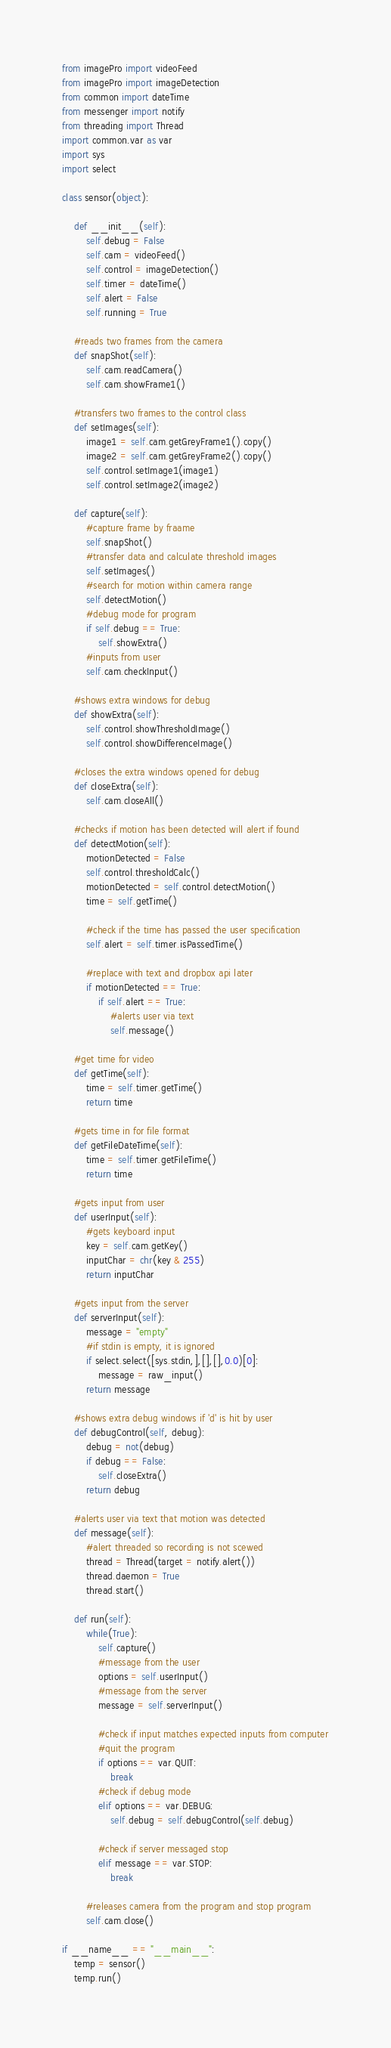Convert code to text. <code><loc_0><loc_0><loc_500><loc_500><_Python_>from imagePro import videoFeed
from imagePro import imageDetection
from common import dateTime
from messenger import notify
from threading import Thread
import common.var as var
import sys
import select

class sensor(object):

    def __init__(self):
        self.debug = False
        self.cam = videoFeed()
        self.control = imageDetection()
        self.timer = dateTime()
        self.alert = False
        self.running = True

    #reads two frames from the camera
    def snapShot(self):
        self.cam.readCamera()
        self.cam.showFrame1()

    #transfers two frames to the control class
    def setImages(self):
        image1 = self.cam.getGreyFrame1().copy()
        image2 = self.cam.getGreyFrame2().copy()
        self.control.setImage1(image1)
        self.control.setImage2(image2)

    def capture(self):
        #capture frame by fraame
        self.snapShot()
        #transfer data and calculate threshold images
        self.setImages()
        #search for motion within camera range
        self.detectMotion()
        #debug mode for program
        if self.debug == True:
            self.showExtra()
        #inputs from user
        self.cam.checkInput()

    #shows extra windows for debug
    def showExtra(self):
        self.control.showThresholdImage()
        self.control.showDifferenceImage()

    #closes the extra windows opened for debug
    def closeExtra(self):
        self.cam.closeAll()

    #checks if motion has been detected will alert if found
    def detectMotion(self):
        motionDetected = False
        self.control.thresholdCalc()
        motionDetected = self.control.detectMotion()
        time = self.getTime()

        #check if the time has passed the user specification
        self.alert = self.timer.isPassedTime()

        #replace with text and dropbox api later
        if motionDetected == True:
            if self.alert == True:
                #alerts user via text
                self.message()

    #get time for video
    def getTime(self):
        time = self.timer.getTime()
        return time

    #gets time in for file format
    def getFileDateTime(self):
        time = self.timer.getFileTime()
        return time

    #gets input from user
    def userInput(self):
        #gets keyboard input
        key = self.cam.getKey()
        inputChar = chr(key & 255)
        return inputChar

    #gets input from the server
    def serverInput(self):
        message = "empty"
        #if stdin is empty, it is ignored
        if select.select([sys.stdin,],[],[],0.0)[0]:
            message = raw_input()
        return message

    #shows extra debug windows if 'd' is hit by user
    def debugControl(self, debug):
        debug = not(debug)
        if debug == False:
            self.closeExtra()
        return debug

    #alerts user via text that motion was detected
    def message(self):
        #alert threaded so recording is not scewed
        thread = Thread(target = notify.alert())
        thread.daemon = True
        thread.start()

    def run(self):
        while(True):
            self.capture()
            #message from the user
            options = self.userInput()
            #message from the server
            message = self.serverInput()

            #check if input matches expected inputs from computer
            #quit the program
            if options == var.QUIT:
                break
            #check if debug mode
            elif options == var.DEBUG:
                self.debug = self.debugControl(self.debug)

            #check if server messaged stop
            elif message == var.STOP:
                break

        #releases camera from the program and stop program
        self.cam.close()

if __name__ == "__main__":
    temp = sensor()
    temp.run()
</code> 